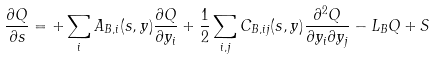Convert formula to latex. <formula><loc_0><loc_0><loc_500><loc_500>\frac { \partial Q } { \partial s } = + \sum _ { i } A _ { B , i } ( s , y ) \frac { \partial Q } { \partial y _ { i } } + \frac { 1 } { 2 } \sum _ { i , j } C _ { B , i j } ( s , y ) \frac { \partial ^ { 2 } Q } { \partial y _ { i } \partial y _ { j } } - L _ { B } Q + S</formula> 